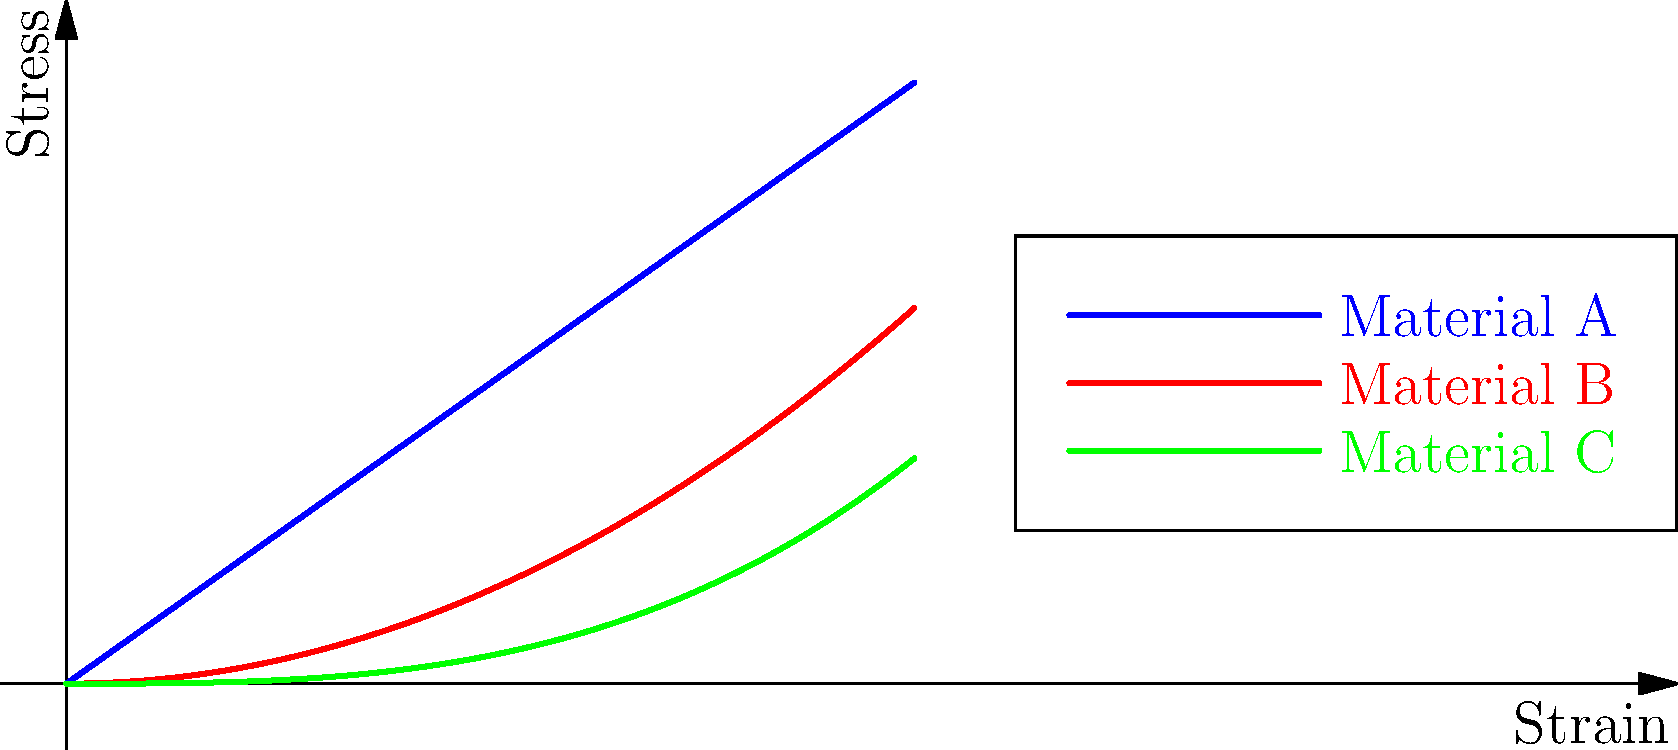Consider the stress-strain curves for three different materials (A, B, and C) under cyclic loading, as shown in the graph. Which material is most likely to exhibit elastic behavior, and why? To determine which material is most likely to exhibit elastic behavior, we need to analyze the stress-strain curves:

1. Material A (blue line):
   - Shows a linear relationship between stress and strain.
   - The slope is constant throughout the curve.
   - This indicates a constant elastic modulus (Young's modulus).

2. Material B (red line):
   - Displays a parabolic curve.
   - The slope increases with increasing strain.
   - This suggests non-linear elastic or early plastic behavior.

3. Material C (green line):
   - Exhibits a cubic relationship between stress and strain.
   - The slope increases more rapidly with strain compared to Material B.
   - This indicates a higher degree of non-linearity and possible plastic deformation.

Elastic behavior is characterized by:
- A linear relationship between stress and strain.
- The ability to return to its original shape when the load is removed.
- A constant elastic modulus.

Among the three materials, Material A demonstrates these characteristics most clearly. Its linear stress-strain relationship suggests that it follows Hooke's Law ($\sigma = E\epsilon$), where $E$ is the elastic modulus.

Materials B and C show non-linear relationships, which could indicate:
- Non-linear elasticity
- The onset of plastic deformation
- More complex material behavior under cyclic loading

Therefore, Material A is most likely to exhibit elastic behavior throughout the range of strains shown in the graph.
Answer: Material A, due to its linear stress-strain relationship. 